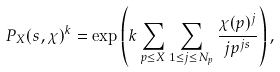Convert formula to latex. <formula><loc_0><loc_0><loc_500><loc_500>P _ { X } ( s , \chi ) ^ { k } = \exp \left ( k \sum _ { p \leq X } \sum _ { 1 \leq j \leq N _ { p } } \frac { \chi ( p ) ^ { j } } { j p ^ { j s } } \right ) ,</formula> 